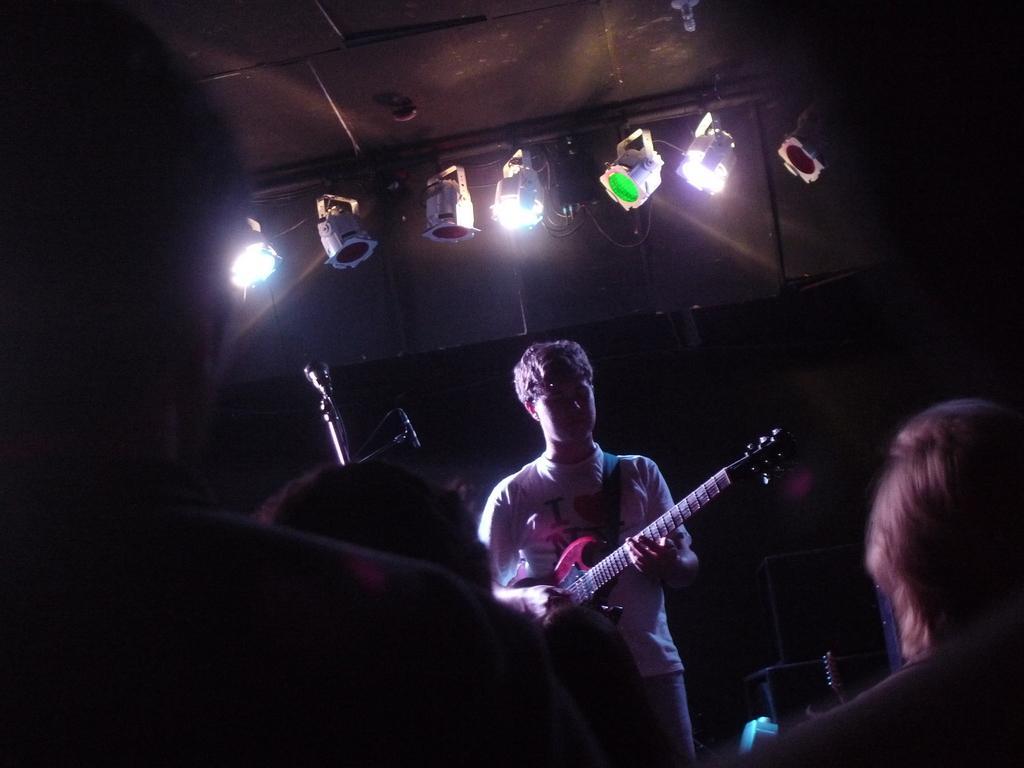Please provide a concise description of this image. In this picture we can see a man holding guitar in his hand and in front of him there are three people and here it is a mic and above him we can see colorful lights. 